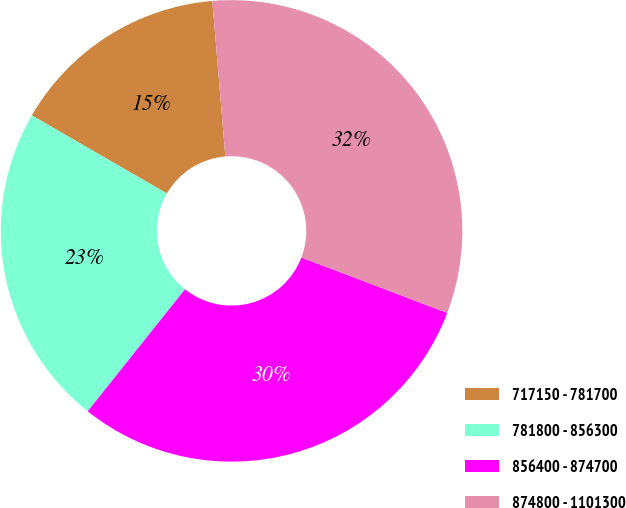Convert chart. <chart><loc_0><loc_0><loc_500><loc_500><pie_chart><fcel>717150 - 781700<fcel>781800 - 856300<fcel>856400 - 874700<fcel>874800 - 1101300<nl><fcel>15.33%<fcel>22.63%<fcel>29.93%<fcel>32.12%<nl></chart> 